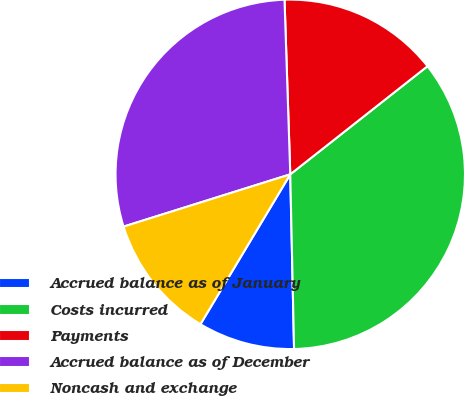<chart> <loc_0><loc_0><loc_500><loc_500><pie_chart><fcel>Accrued balance as of January<fcel>Costs incurred<fcel>Payments<fcel>Accrued balance as of December<fcel>Noncash and exchange<nl><fcel>8.94%<fcel>35.27%<fcel>14.9%<fcel>29.31%<fcel>11.57%<nl></chart> 